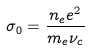<formula> <loc_0><loc_0><loc_500><loc_500>\sigma _ { 0 } = \frac { n _ { e } e ^ { 2 } } { m _ { e } \nu _ { c } }</formula> 